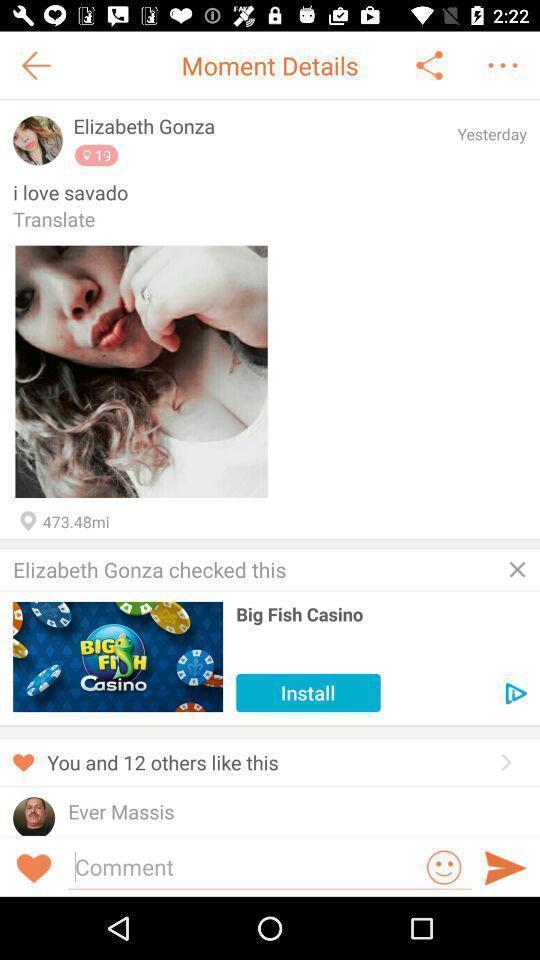Provide a detailed account of this screenshot. Screen shows different moment details. 